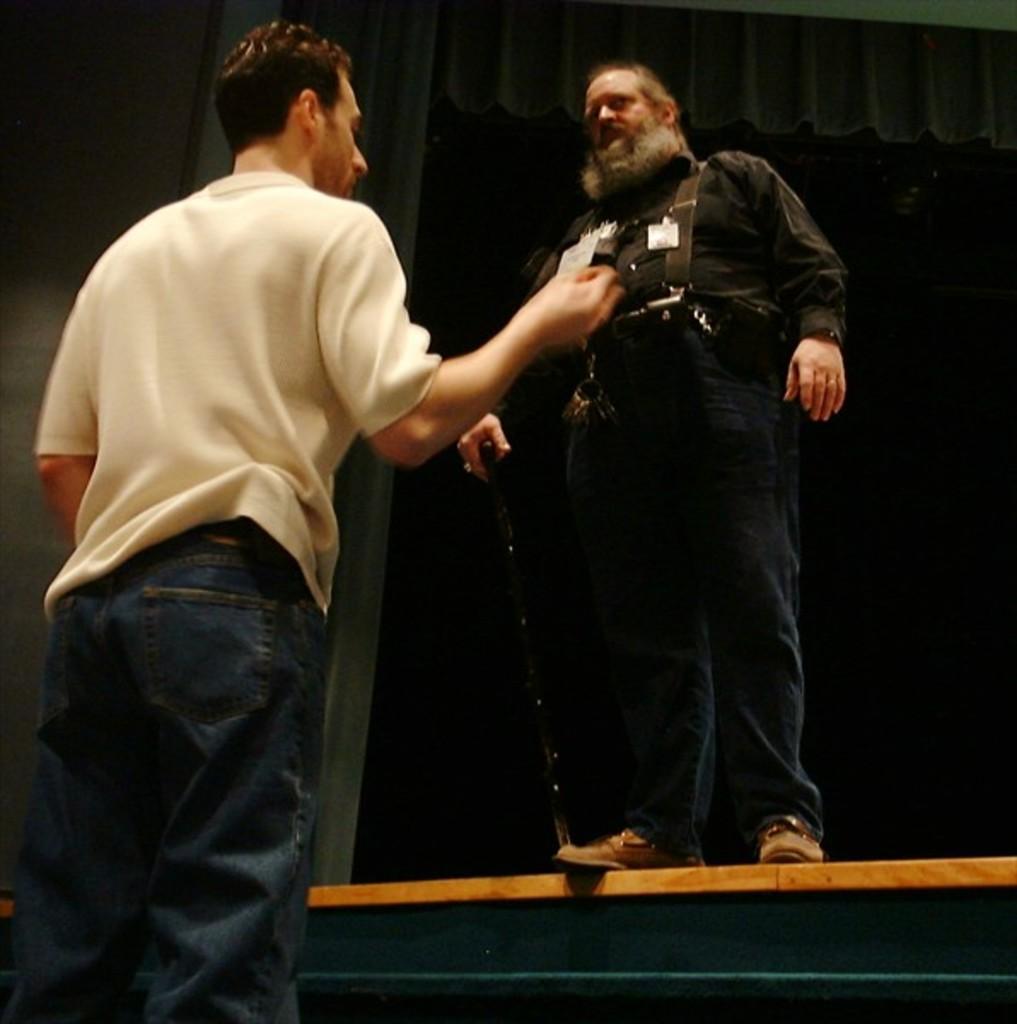How would you summarize this image in a sentence or two? In this picture we can see two men, and the right side person is holding a stick, and we can find dark background. 